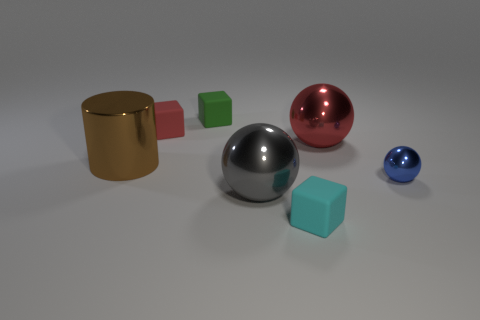Subtract all yellow spheres. Subtract all brown cubes. How many spheres are left? 3 Add 3 brown cylinders. How many objects exist? 10 Subtract all balls. How many objects are left? 4 Subtract 0 green cylinders. How many objects are left? 7 Subtract all tiny blue metal cylinders. Subtract all brown metallic cylinders. How many objects are left? 6 Add 6 red spheres. How many red spheres are left? 7 Add 3 tiny cyan cubes. How many tiny cyan cubes exist? 4 